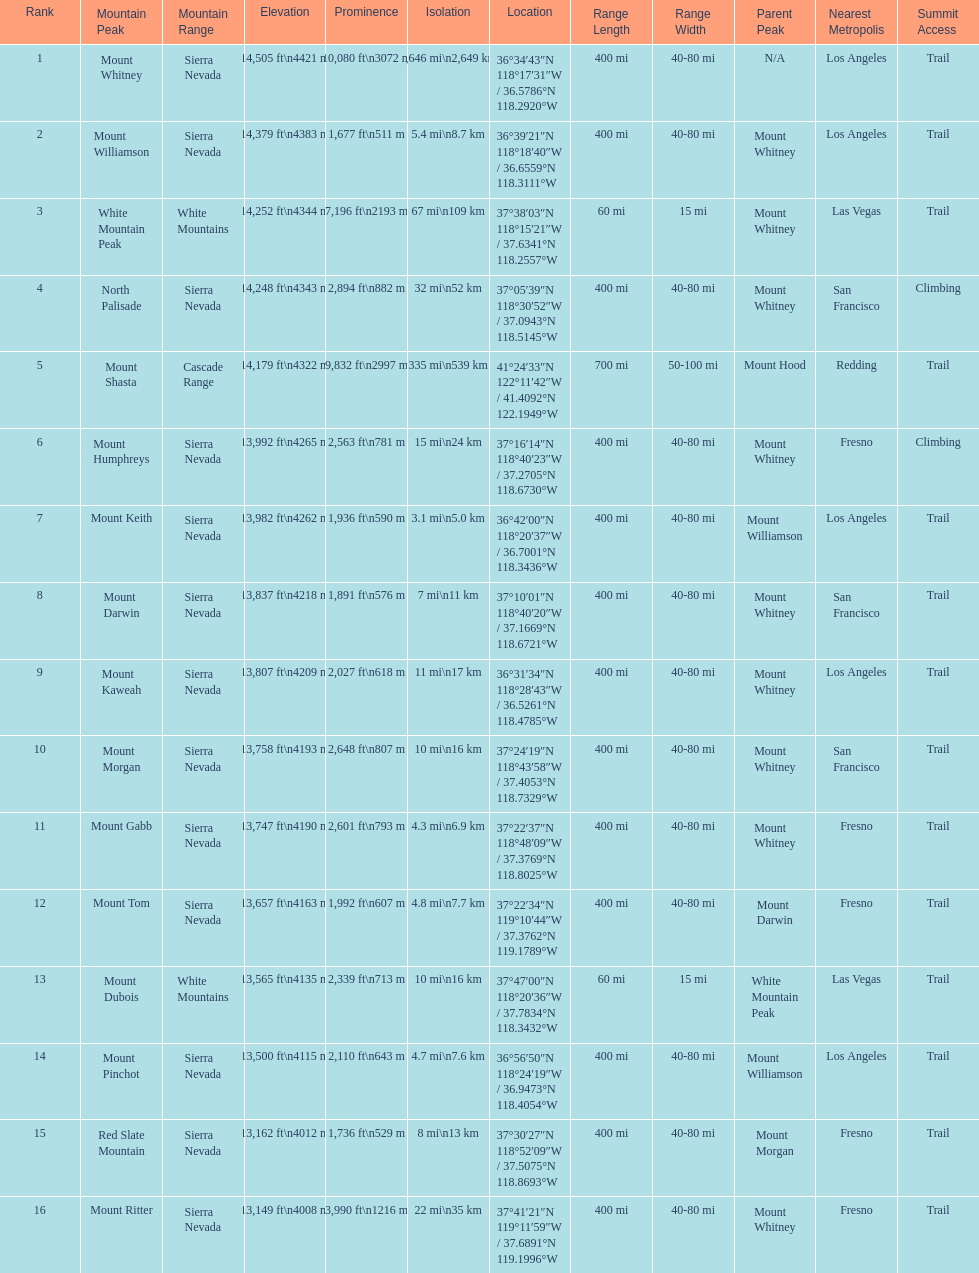Which mountain peak has the most isolation? Mount Whitney. 